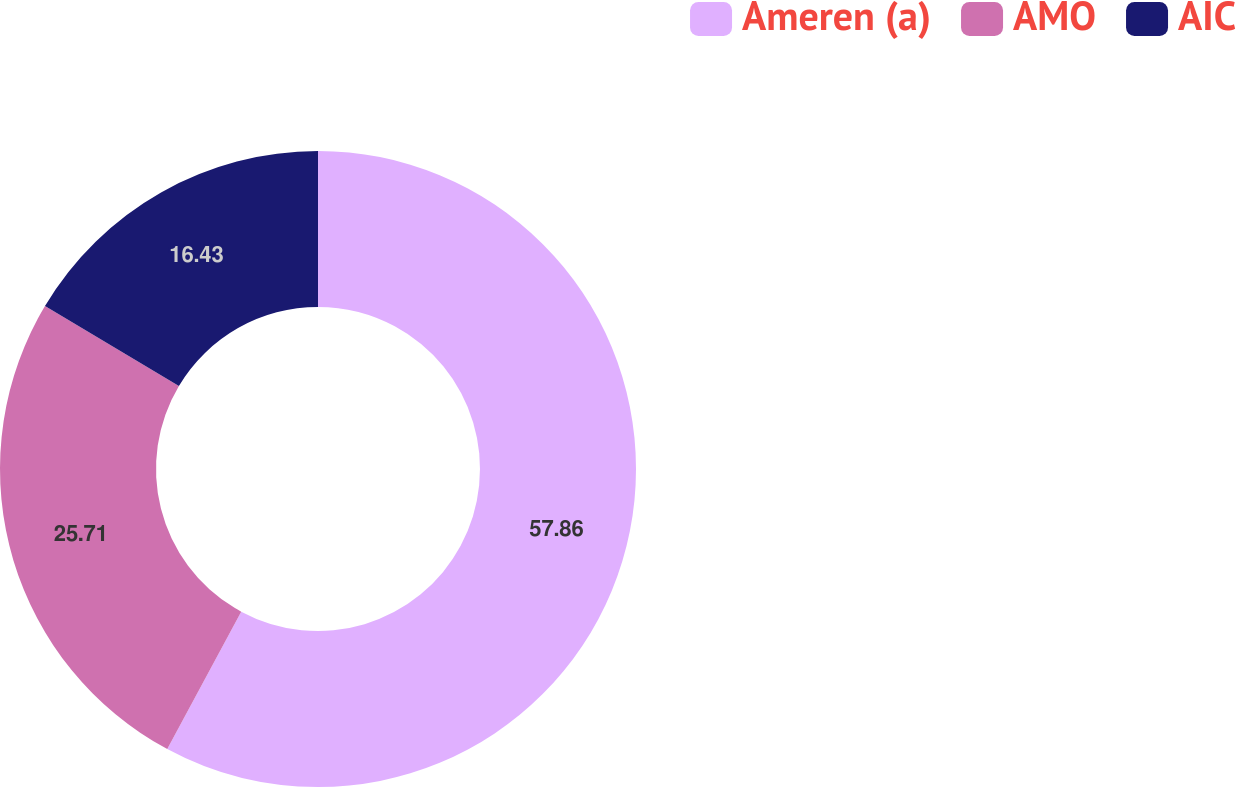Convert chart. <chart><loc_0><loc_0><loc_500><loc_500><pie_chart><fcel>Ameren (a)<fcel>AMO<fcel>AIC<nl><fcel>57.86%<fcel>25.71%<fcel>16.43%<nl></chart> 